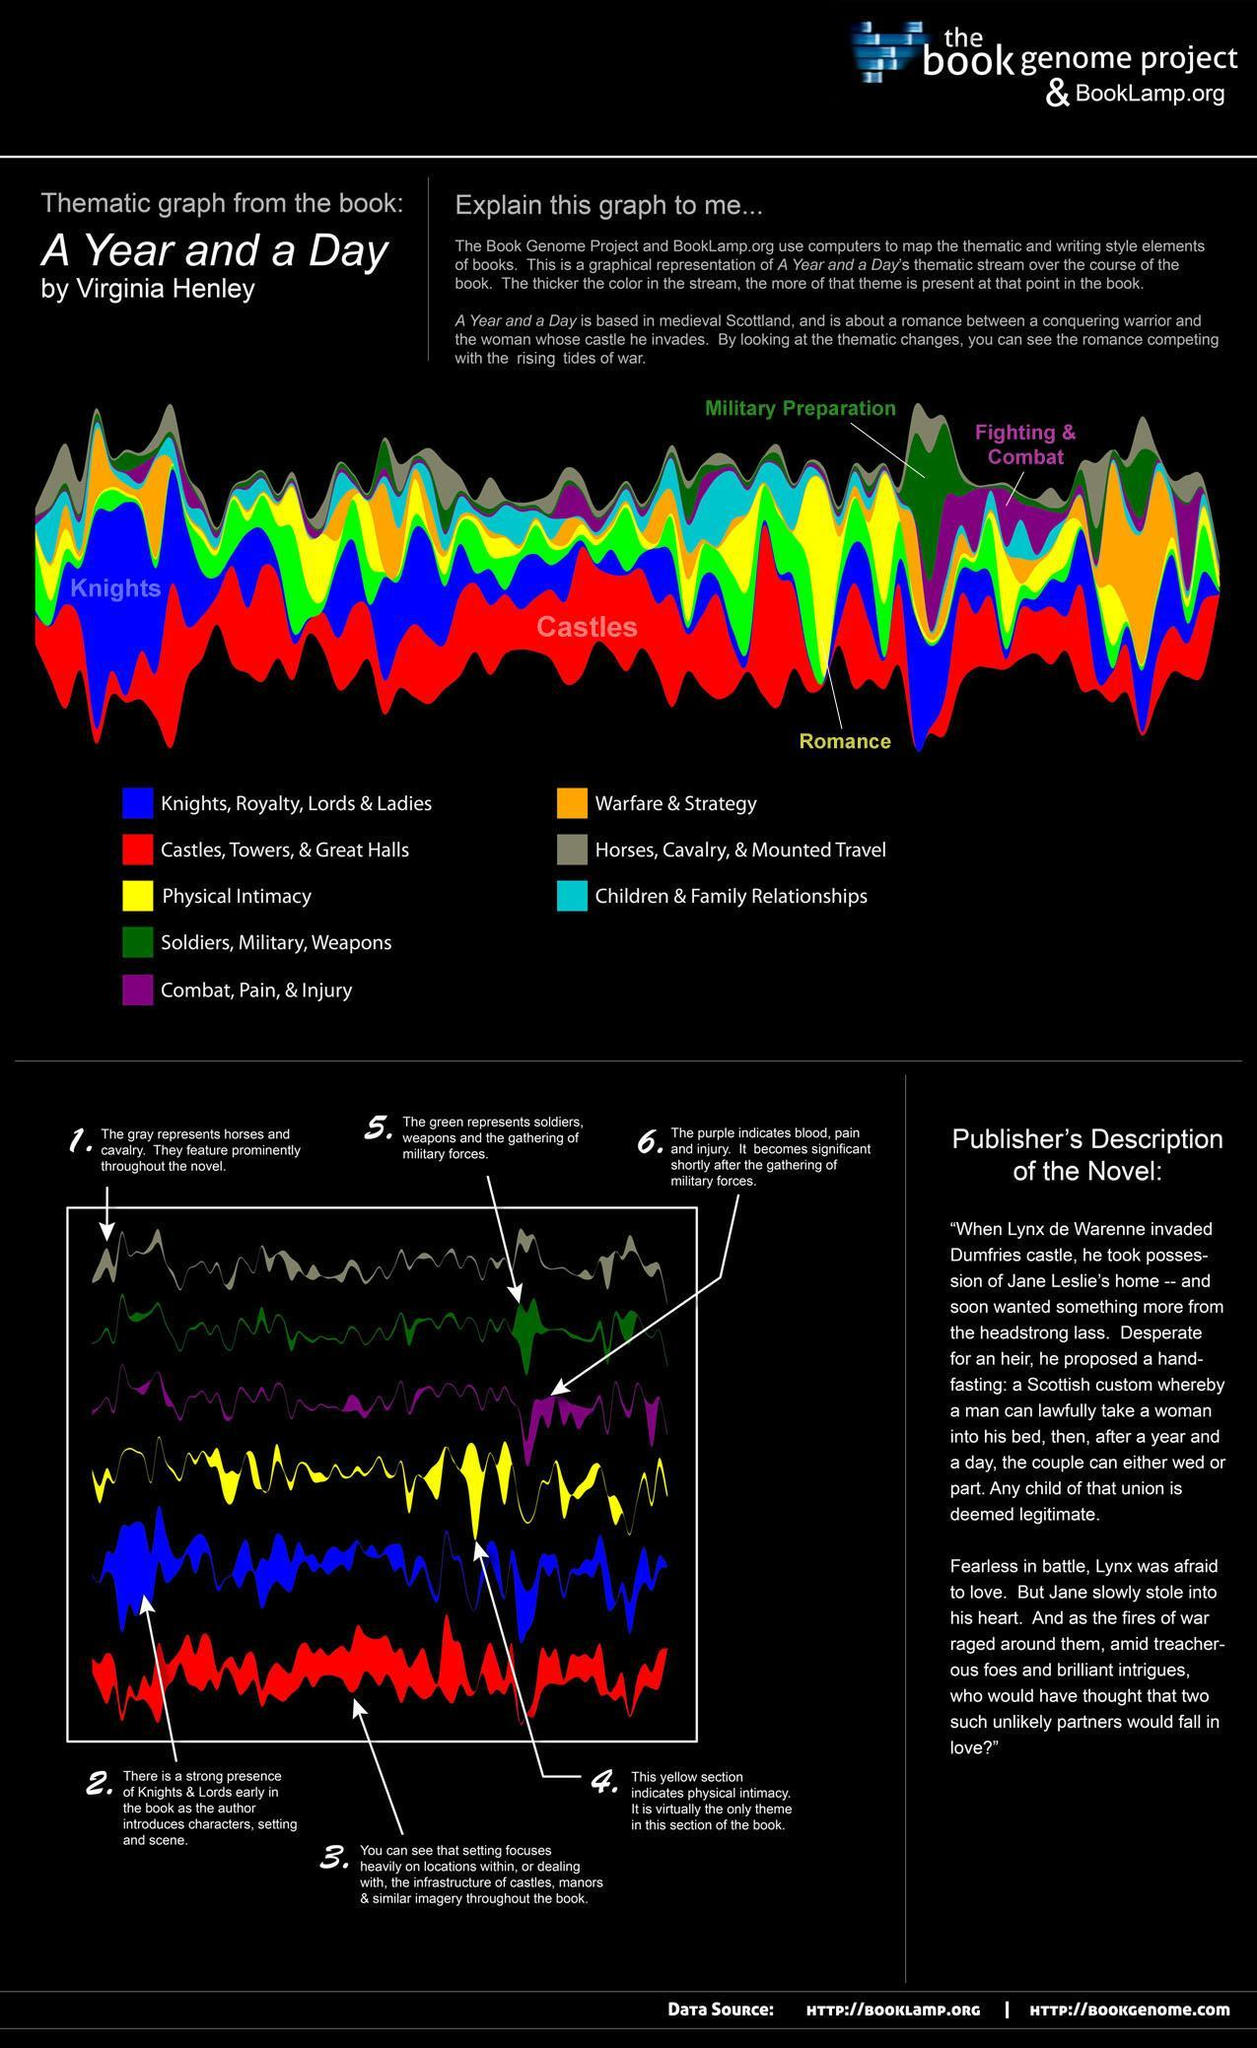Which color used to represent Warefare & Strategy-red, orange, green?
Answer the question with a short phrase. orange Which color used to represent Physical Intimacy-red, yellow, orange? yellow 